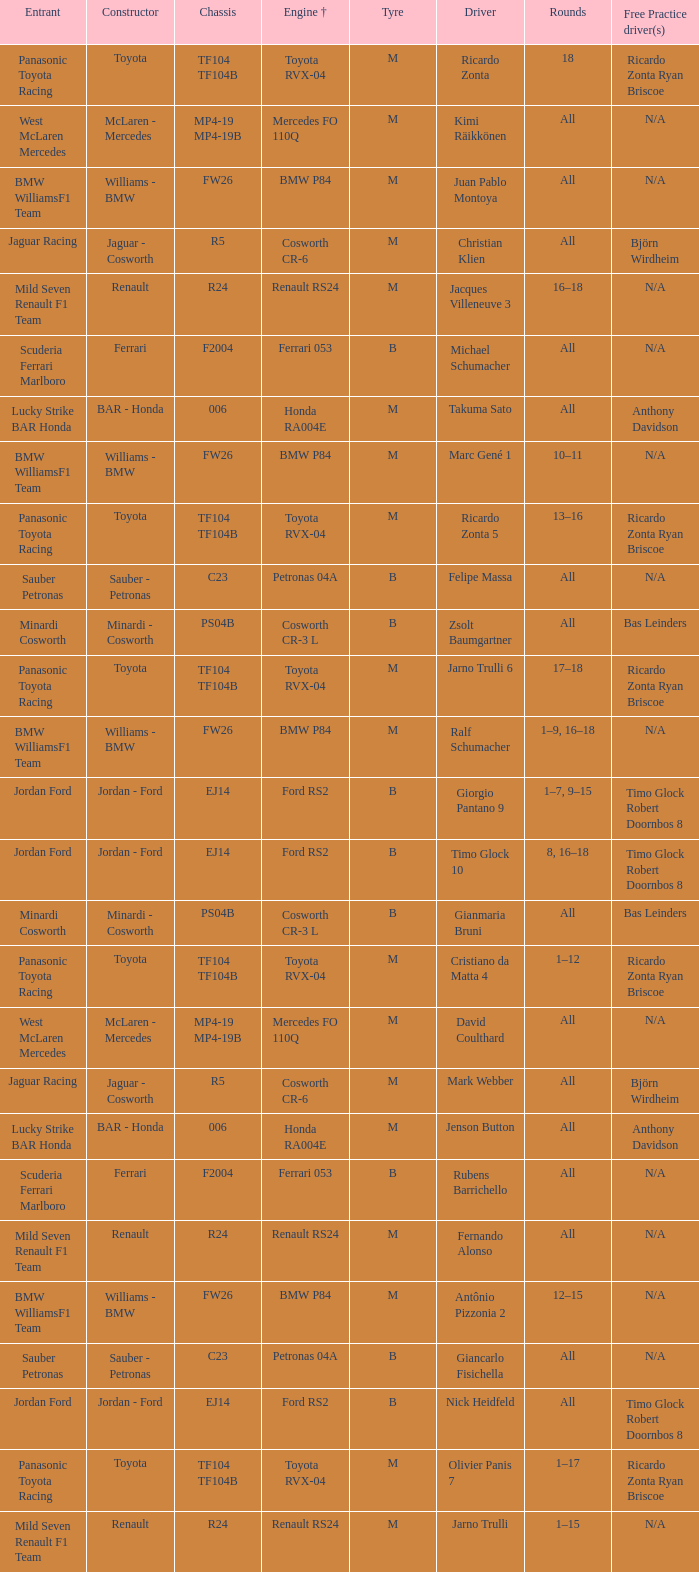What kind of chassis does Ricardo Zonta have? TF104 TF104B. Give me the full table as a dictionary. {'header': ['Entrant', 'Constructor', 'Chassis', 'Engine †', 'Tyre', 'Driver', 'Rounds', 'Free Practice driver(s)'], 'rows': [['Panasonic Toyota Racing', 'Toyota', 'TF104 TF104B', 'Toyota RVX-04', 'M', 'Ricardo Zonta', '18', 'Ricardo Zonta Ryan Briscoe'], ['West McLaren Mercedes', 'McLaren - Mercedes', 'MP4-19 MP4-19B', 'Mercedes FO 110Q', 'M', 'Kimi Räikkönen', 'All', 'N/A'], ['BMW WilliamsF1 Team', 'Williams - BMW', 'FW26', 'BMW P84', 'M', 'Juan Pablo Montoya', 'All', 'N/A'], ['Jaguar Racing', 'Jaguar - Cosworth', 'R5', 'Cosworth CR-6', 'M', 'Christian Klien', 'All', 'Björn Wirdheim'], ['Mild Seven Renault F1 Team', 'Renault', 'R24', 'Renault RS24', 'M', 'Jacques Villeneuve 3', '16–18', 'N/A'], ['Scuderia Ferrari Marlboro', 'Ferrari', 'F2004', 'Ferrari 053', 'B', 'Michael Schumacher', 'All', 'N/A'], ['Lucky Strike BAR Honda', 'BAR - Honda', '006', 'Honda RA004E', 'M', 'Takuma Sato', 'All', 'Anthony Davidson'], ['BMW WilliamsF1 Team', 'Williams - BMW', 'FW26', 'BMW P84', 'M', 'Marc Gené 1', '10–11', 'N/A'], ['Panasonic Toyota Racing', 'Toyota', 'TF104 TF104B', 'Toyota RVX-04', 'M', 'Ricardo Zonta 5', '13–16', 'Ricardo Zonta Ryan Briscoe'], ['Sauber Petronas', 'Sauber - Petronas', 'C23', 'Petronas 04A', 'B', 'Felipe Massa', 'All', 'N/A'], ['Minardi Cosworth', 'Minardi - Cosworth', 'PS04B', 'Cosworth CR-3 L', 'B', 'Zsolt Baumgartner', 'All', 'Bas Leinders'], ['Panasonic Toyota Racing', 'Toyota', 'TF104 TF104B', 'Toyota RVX-04', 'M', 'Jarno Trulli 6', '17–18', 'Ricardo Zonta Ryan Briscoe'], ['BMW WilliamsF1 Team', 'Williams - BMW', 'FW26', 'BMW P84', 'M', 'Ralf Schumacher', '1–9, 16–18', 'N/A'], ['Jordan Ford', 'Jordan - Ford', 'EJ14', 'Ford RS2', 'B', 'Giorgio Pantano 9', '1–7, 9–15', 'Timo Glock Robert Doornbos 8'], ['Jordan Ford', 'Jordan - Ford', 'EJ14', 'Ford RS2', 'B', 'Timo Glock 10', '8, 16–18', 'Timo Glock Robert Doornbos 8'], ['Minardi Cosworth', 'Minardi - Cosworth', 'PS04B', 'Cosworth CR-3 L', 'B', 'Gianmaria Bruni', 'All', 'Bas Leinders'], ['Panasonic Toyota Racing', 'Toyota', 'TF104 TF104B', 'Toyota RVX-04', 'M', 'Cristiano da Matta 4', '1–12', 'Ricardo Zonta Ryan Briscoe'], ['West McLaren Mercedes', 'McLaren - Mercedes', 'MP4-19 MP4-19B', 'Mercedes FO 110Q', 'M', 'David Coulthard', 'All', 'N/A'], ['Jaguar Racing', 'Jaguar - Cosworth', 'R5', 'Cosworth CR-6', 'M', 'Mark Webber', 'All', 'Björn Wirdheim'], ['Lucky Strike BAR Honda', 'BAR - Honda', '006', 'Honda RA004E', 'M', 'Jenson Button', 'All', 'Anthony Davidson'], ['Scuderia Ferrari Marlboro', 'Ferrari', 'F2004', 'Ferrari 053', 'B', 'Rubens Barrichello', 'All', 'N/A'], ['Mild Seven Renault F1 Team', 'Renault', 'R24', 'Renault RS24', 'M', 'Fernando Alonso', 'All', 'N/A'], ['BMW WilliamsF1 Team', 'Williams - BMW', 'FW26', 'BMW P84', 'M', 'Antônio Pizzonia 2', '12–15', 'N/A'], ['Sauber Petronas', 'Sauber - Petronas', 'C23', 'Petronas 04A', 'B', 'Giancarlo Fisichella', 'All', 'N/A'], ['Jordan Ford', 'Jordan - Ford', 'EJ14', 'Ford RS2', 'B', 'Nick Heidfeld', 'All', 'Timo Glock Robert Doornbos 8'], ['Panasonic Toyota Racing', 'Toyota', 'TF104 TF104B', 'Toyota RVX-04', 'M', 'Olivier Panis 7', '1–17', 'Ricardo Zonta Ryan Briscoe'], ['Mild Seven Renault F1 Team', 'Renault', 'R24', 'Renault RS24', 'M', 'Jarno Trulli', '1–15', 'N/A']]} 